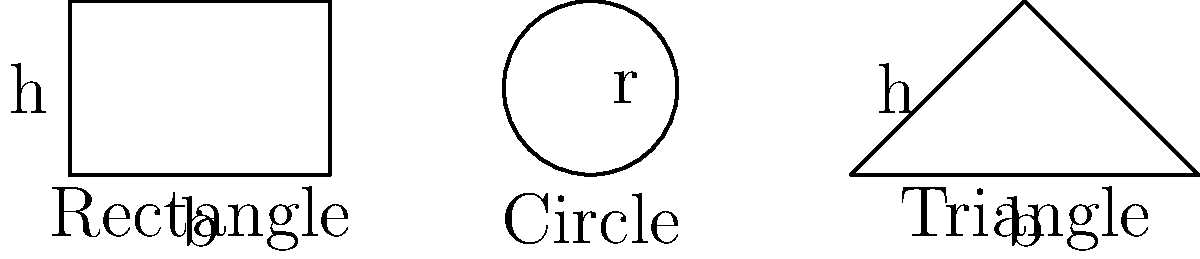As an aspiring musician who's into structural shapes (just like how Chester Bennington's voice shaped Linkin Park's sound), you're curious about cross-sectional areas. If the rectangle has a base (b) of 3 units and height (h) of 2 units, the circle has a radius (r) of 1 unit, and the triangle has a base (b) of 4 units and height (h) of 2 units, which shape has the largest cross-sectional area? Let's calculate the area of each shape step by step:

1. Rectangle:
   Area = base × height
   $A_r = b \times h = 3 \times 2 = 6$ square units

2. Circle:
   Area = π × radius²
   $A_c = \pi r^2 = \pi \times 1^2 = \pi \approx 3.14$ square units

3. Triangle:
   Area = ½ × base × height
   $A_t = \frac{1}{2} \times b \times h = \frac{1}{2} \times 4 \times 2 = 4$ square units

Comparing the areas:
Rectangle: 6 square units
Circle: 3.14 square units
Triangle: 4 square units

The rectangle has the largest cross-sectional area among the three shapes.
Answer: Rectangle 